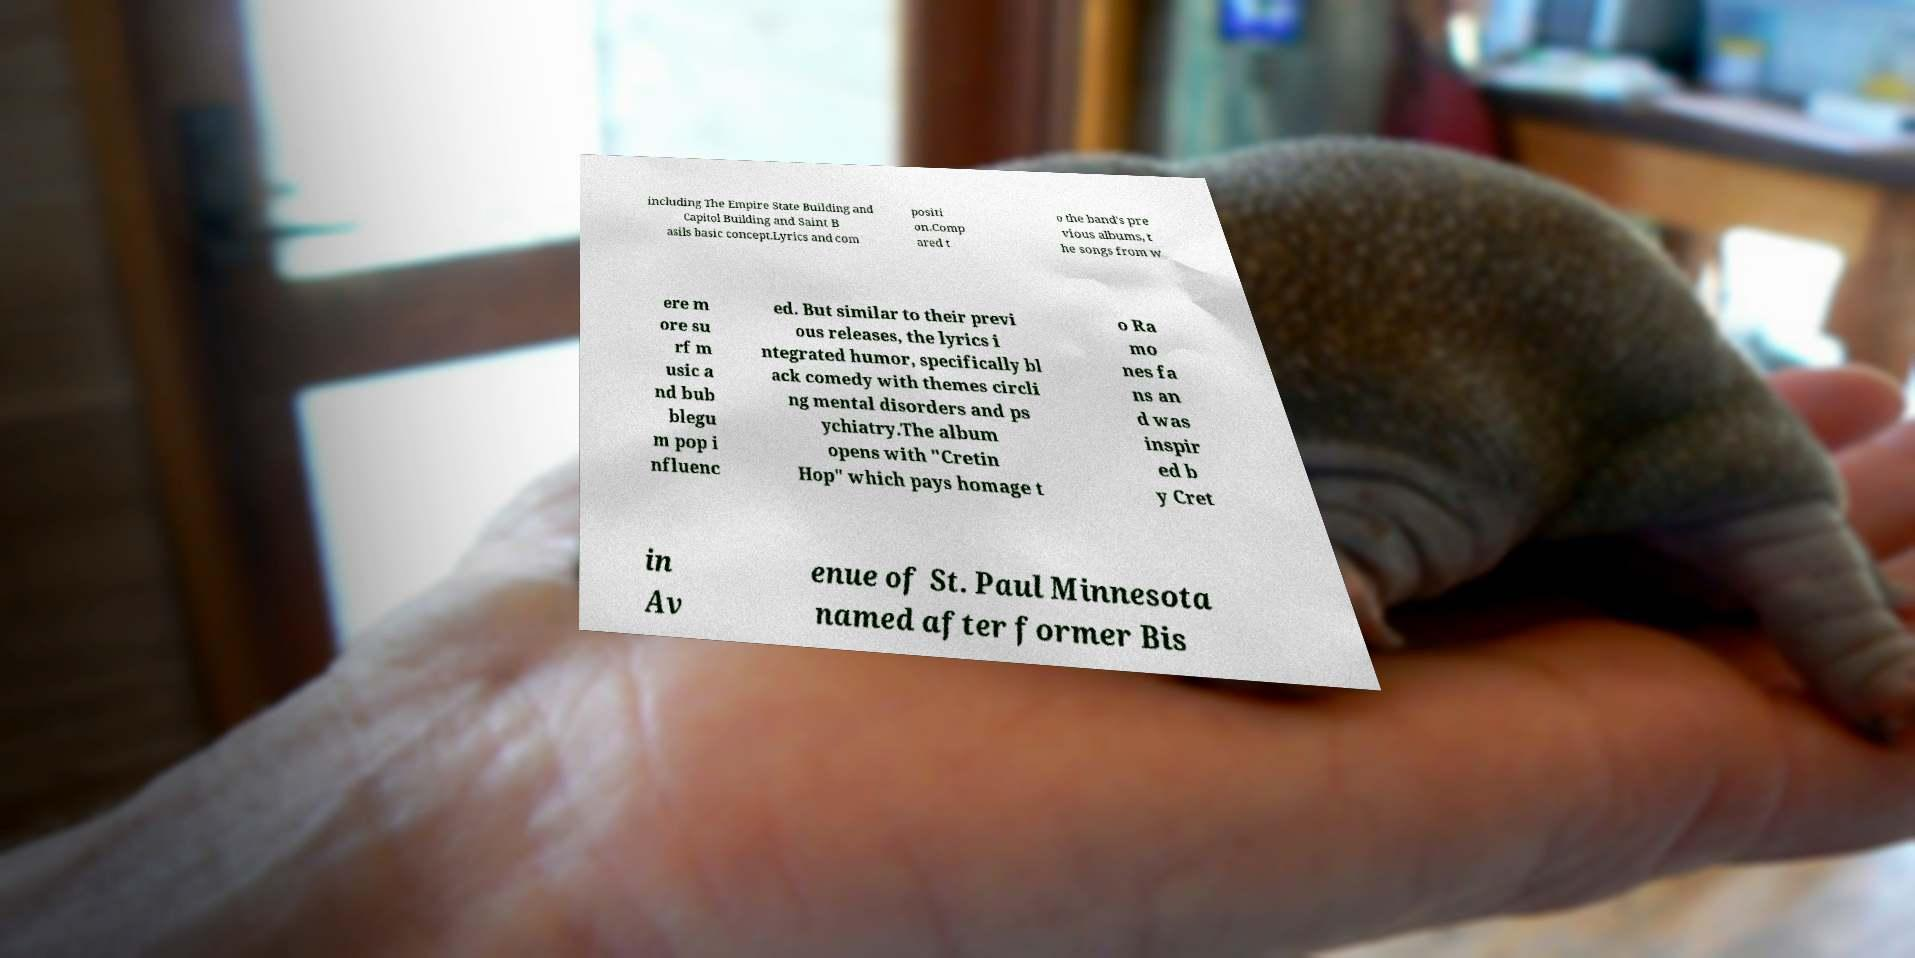There's text embedded in this image that I need extracted. Can you transcribe it verbatim? including The Empire State Building and Capitol Building and Saint B asils basic concept.Lyrics and com positi on.Comp ared t o the band's pre vious albums, t he songs from w ere m ore su rf m usic a nd bub blegu m pop i nfluenc ed. But similar to their previ ous releases, the lyrics i ntegrated humor, specifically bl ack comedy with themes circli ng mental disorders and ps ychiatry.The album opens with "Cretin Hop" which pays homage t o Ra mo nes fa ns an d was inspir ed b y Cret in Av enue of St. Paul Minnesota named after former Bis 